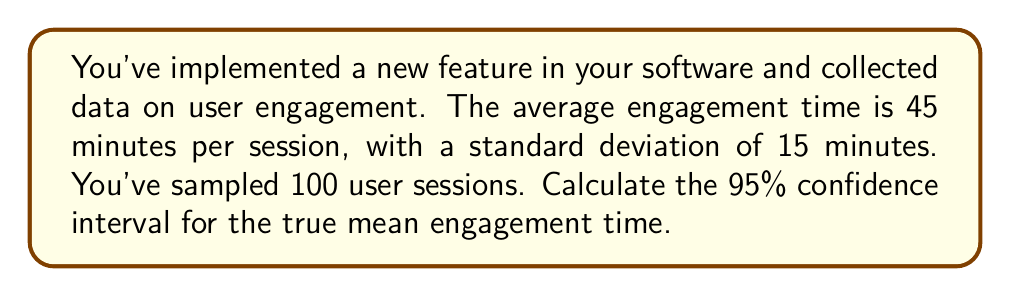Show me your answer to this math problem. Let's approach this step-by-step:

1) We're dealing with a confidence interval for a population mean, where the population standard deviation is unknown. This calls for the use of the t-distribution.

2) The formula for the confidence interval is:

   $$ \bar{x} \pm t_{\alpha/2, n-1} \cdot \frac{s}{\sqrt{n}} $$

   Where:
   - $\bar{x}$ is the sample mean (45 minutes)
   - $s$ is the sample standard deviation (15 minutes)
   - $n$ is the sample size (100)
   - $t_{\alpha/2, n-1}$ is the t-value for a 95% confidence interval with n-1 degrees of freedom

3) For a 95% confidence interval, $\alpha = 0.05$, and we need $t_{0.025, 99}$

4) Looking up the t-value in a t-table (or using a calculator), we find:
   $t_{0.025, 99} \approx 1.984$

5) Now, let's plug everything into our formula:

   $$ 45 \pm 1.984 \cdot \frac{15}{\sqrt{100}} $$

6) Simplify:
   $$ 45 \pm 1.984 \cdot 1.5 $$
   $$ 45 \pm 2.976 $$

7) Therefore, the confidence interval is:
   $$ (42.024, 47.976) $$
Answer: (42.024, 47.976) minutes 